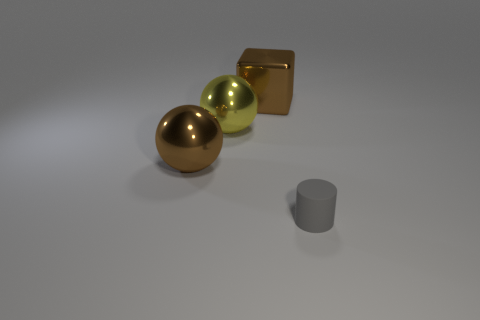Can you tell me the colors of the objects starting from the left? From left to right, the colors of the objects are gold, green, gold (the cube behind), and gray (the cylinder). 